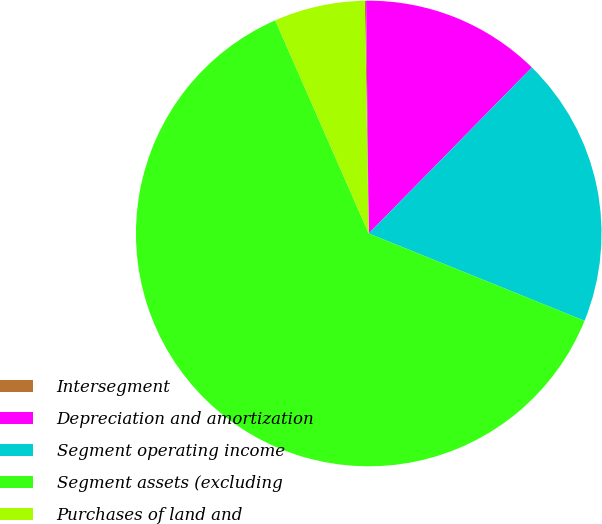<chart> <loc_0><loc_0><loc_500><loc_500><pie_chart><fcel>Intersegment<fcel>Depreciation and amortization<fcel>Segment operating income<fcel>Segment assets (excluding<fcel>Purchases of land and<nl><fcel>0.09%<fcel>12.54%<fcel>18.76%<fcel>62.3%<fcel>6.31%<nl></chart> 